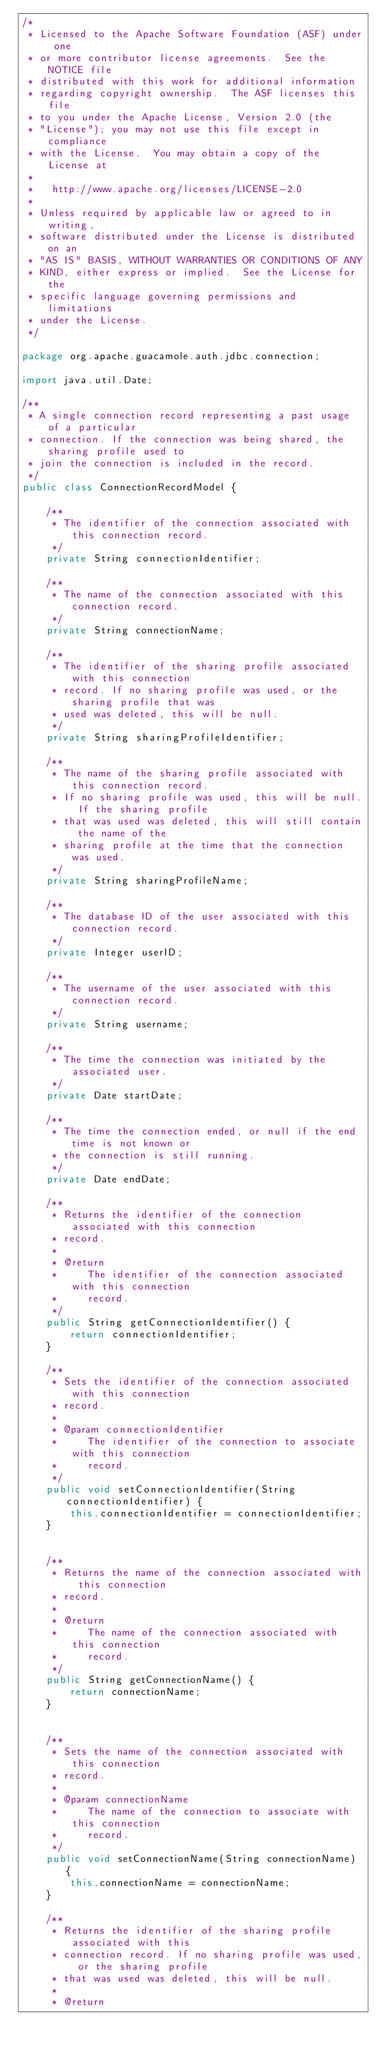Convert code to text. <code><loc_0><loc_0><loc_500><loc_500><_Java_>/*
 * Licensed to the Apache Software Foundation (ASF) under one
 * or more contributor license agreements.  See the NOTICE file
 * distributed with this work for additional information
 * regarding copyright ownership.  The ASF licenses this file
 * to you under the Apache License, Version 2.0 (the
 * "License"); you may not use this file except in compliance
 * with the License.  You may obtain a copy of the License at
 *
 *   http://www.apache.org/licenses/LICENSE-2.0
 *
 * Unless required by applicable law or agreed to in writing,
 * software distributed under the License is distributed on an
 * "AS IS" BASIS, WITHOUT WARRANTIES OR CONDITIONS OF ANY
 * KIND, either express or implied.  See the License for the
 * specific language governing permissions and limitations
 * under the License.
 */

package org.apache.guacamole.auth.jdbc.connection;

import java.util.Date;

/**
 * A single connection record representing a past usage of a particular
 * connection. If the connection was being shared, the sharing profile used to
 * join the connection is included in the record.
 */
public class ConnectionRecordModel {

    /**
     * The identifier of the connection associated with this connection record.
     */
    private String connectionIdentifier;

    /**
     * The name of the connection associated with this connection record.
     */
    private String connectionName;

    /**
     * The identifier of the sharing profile associated with this connection
     * record. If no sharing profile was used, or the sharing profile that was
     * used was deleted, this will be null.
     */
    private String sharingProfileIdentifier;

    /**
     * The name of the sharing profile associated with this connection record.
     * If no sharing profile was used, this will be null. If the sharing profile
     * that was used was deleted, this will still contain the name of the
     * sharing profile at the time that the connection was used.
     */
    private String sharingProfileName;

    /**
     * The database ID of the user associated with this connection record.
     */
    private Integer userID;

    /**
     * The username of the user associated with this connection record.
     */
    private String username;

    /**
     * The time the connection was initiated by the associated user.
     */
    private Date startDate;

    /**
     * The time the connection ended, or null if the end time is not known or
     * the connection is still running.
     */
    private Date endDate;

    /**
     * Returns the identifier of the connection associated with this connection
     * record.
     *
     * @return
     *     The identifier of the connection associated with this connection
     *     record.
     */
    public String getConnectionIdentifier() {
        return connectionIdentifier;
    }

    /**
     * Sets the identifier of the connection associated with this connection
     * record.
     *
     * @param connectionIdentifier
     *     The identifier of the connection to associate with this connection
     *     record.
     */
    public void setConnectionIdentifier(String connectionIdentifier) {
        this.connectionIdentifier = connectionIdentifier;
    }


    /**
     * Returns the name of the connection associated with this connection
     * record.
     *
     * @return
     *     The name of the connection associated with this connection
     *     record.
     */
    public String getConnectionName() {
        return connectionName;
    }


    /**
     * Sets the name of the connection associated with this connection
     * record.
     *
     * @param connectionName
     *     The name of the connection to associate with this connection
     *     record.
     */
    public void setConnectionName(String connectionName) {
        this.connectionName = connectionName;
    }

    /**
     * Returns the identifier of the sharing profile associated with this
     * connection record. If no sharing profile was used, or the sharing profile
     * that was used was deleted, this will be null.
     *
     * @return</code> 